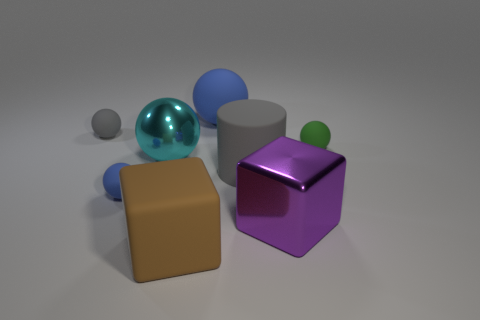Subtract all gray balls. How many balls are left? 4 Subtract all gray balls. How many balls are left? 4 Subtract all purple spheres. Subtract all green cylinders. How many spheres are left? 5 Add 2 yellow blocks. How many objects exist? 10 Subtract all cylinders. How many objects are left? 7 Add 1 metallic blocks. How many metallic blocks exist? 2 Subtract 0 cyan cylinders. How many objects are left? 8 Subtract all large purple shiny cylinders. Subtract all large cyan objects. How many objects are left? 7 Add 1 tiny spheres. How many tiny spheres are left? 4 